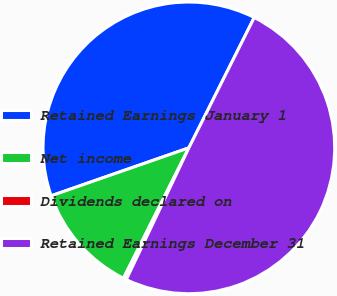Convert chart to OTSL. <chart><loc_0><loc_0><loc_500><loc_500><pie_chart><fcel>Retained Earnings January 1<fcel>Net income<fcel>Dividends declared on<fcel>Retained Earnings December 31<nl><fcel>37.73%<fcel>12.27%<fcel>0.34%<fcel>49.66%<nl></chart> 